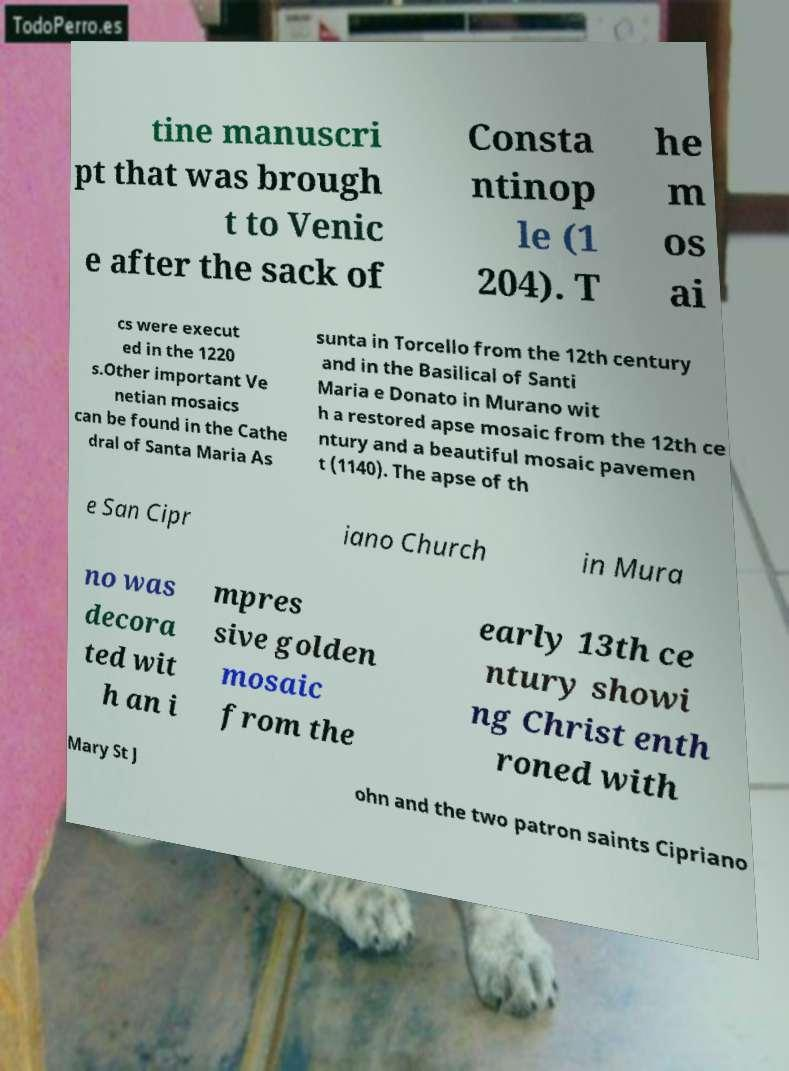Can you accurately transcribe the text from the provided image for me? tine manuscri pt that was brough t to Venic e after the sack of Consta ntinop le (1 204). T he m os ai cs were execut ed in the 1220 s.Other important Ve netian mosaics can be found in the Cathe dral of Santa Maria As sunta in Torcello from the 12th century and in the Basilical of Santi Maria e Donato in Murano wit h a restored apse mosaic from the 12th ce ntury and a beautiful mosaic pavemen t (1140). The apse of th e San Cipr iano Church in Mura no was decora ted wit h an i mpres sive golden mosaic from the early 13th ce ntury showi ng Christ enth roned with Mary St J ohn and the two patron saints Cipriano 